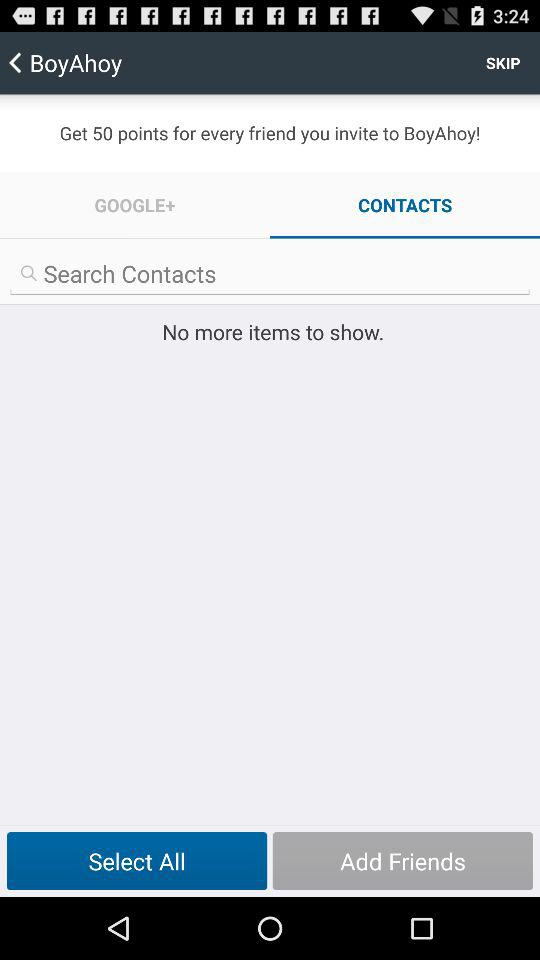How many friends have been added?
When the provided information is insufficient, respond with <no answer>. <no answer> 